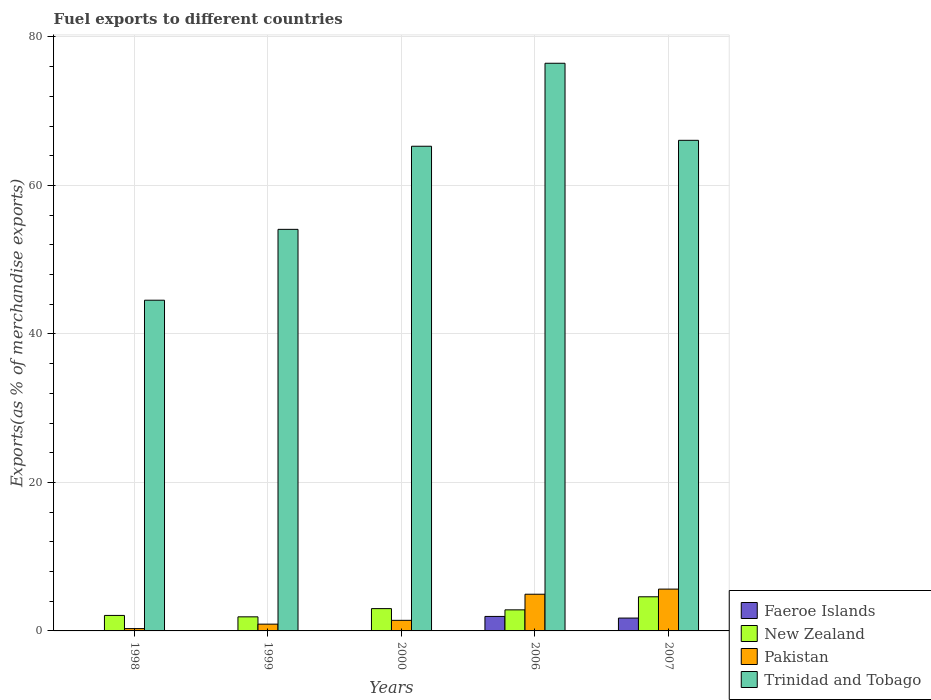How many different coloured bars are there?
Offer a terse response. 4. Are the number of bars per tick equal to the number of legend labels?
Your answer should be very brief. Yes. Are the number of bars on each tick of the X-axis equal?
Your answer should be very brief. Yes. How many bars are there on the 4th tick from the left?
Your answer should be compact. 4. How many bars are there on the 5th tick from the right?
Make the answer very short. 4. What is the label of the 1st group of bars from the left?
Make the answer very short. 1998. What is the percentage of exports to different countries in Trinidad and Tobago in 2007?
Your answer should be very brief. 66.08. Across all years, what is the maximum percentage of exports to different countries in Pakistan?
Give a very brief answer. 5.63. Across all years, what is the minimum percentage of exports to different countries in Faeroe Islands?
Provide a short and direct response. 5.55871303274651e-5. In which year was the percentage of exports to different countries in New Zealand maximum?
Offer a terse response. 2007. In which year was the percentage of exports to different countries in Pakistan minimum?
Give a very brief answer. 1998. What is the total percentage of exports to different countries in Pakistan in the graph?
Give a very brief answer. 13.23. What is the difference between the percentage of exports to different countries in Pakistan in 1998 and that in 2007?
Your answer should be very brief. -5.32. What is the difference between the percentage of exports to different countries in Trinidad and Tobago in 2000 and the percentage of exports to different countries in Pakistan in 1999?
Provide a short and direct response. 64.37. What is the average percentage of exports to different countries in Trinidad and Tobago per year?
Your response must be concise. 61.29. In the year 2007, what is the difference between the percentage of exports to different countries in Pakistan and percentage of exports to different countries in New Zealand?
Your answer should be very brief. 1.04. In how many years, is the percentage of exports to different countries in New Zealand greater than 4 %?
Your answer should be very brief. 1. What is the ratio of the percentage of exports to different countries in New Zealand in 1998 to that in 2000?
Offer a terse response. 0.69. Is the percentage of exports to different countries in New Zealand in 1998 less than that in 2006?
Your answer should be very brief. Yes. What is the difference between the highest and the second highest percentage of exports to different countries in Pakistan?
Your answer should be compact. 0.69. What is the difference between the highest and the lowest percentage of exports to different countries in Faeroe Islands?
Offer a very short reply. 1.95. In how many years, is the percentage of exports to different countries in New Zealand greater than the average percentage of exports to different countries in New Zealand taken over all years?
Offer a terse response. 2. What does the 1st bar from the left in 2006 represents?
Your answer should be compact. Faeroe Islands. Is it the case that in every year, the sum of the percentage of exports to different countries in Trinidad and Tobago and percentage of exports to different countries in New Zealand is greater than the percentage of exports to different countries in Faeroe Islands?
Offer a terse response. Yes. How many bars are there?
Ensure brevity in your answer.  20. Are all the bars in the graph horizontal?
Offer a terse response. No. What is the difference between two consecutive major ticks on the Y-axis?
Provide a short and direct response. 20. Are the values on the major ticks of Y-axis written in scientific E-notation?
Your answer should be compact. No. Does the graph contain any zero values?
Provide a succinct answer. No. Does the graph contain grids?
Ensure brevity in your answer.  Yes. How are the legend labels stacked?
Give a very brief answer. Vertical. What is the title of the graph?
Provide a short and direct response. Fuel exports to different countries. Does "Middle income" appear as one of the legend labels in the graph?
Your response must be concise. No. What is the label or title of the X-axis?
Make the answer very short. Years. What is the label or title of the Y-axis?
Provide a short and direct response. Exports(as % of merchandise exports). What is the Exports(as % of merchandise exports) in Faeroe Islands in 1998?
Your response must be concise. 0. What is the Exports(as % of merchandise exports) of New Zealand in 1998?
Make the answer very short. 2.09. What is the Exports(as % of merchandise exports) in Pakistan in 1998?
Ensure brevity in your answer.  0.31. What is the Exports(as % of merchandise exports) in Trinidad and Tobago in 1998?
Offer a very short reply. 44.54. What is the Exports(as % of merchandise exports) in Faeroe Islands in 1999?
Give a very brief answer. 0. What is the Exports(as % of merchandise exports) of New Zealand in 1999?
Your answer should be very brief. 1.9. What is the Exports(as % of merchandise exports) in Pakistan in 1999?
Your response must be concise. 0.91. What is the Exports(as % of merchandise exports) of Trinidad and Tobago in 1999?
Your response must be concise. 54.08. What is the Exports(as % of merchandise exports) in Faeroe Islands in 2000?
Give a very brief answer. 5.55871303274651e-5. What is the Exports(as % of merchandise exports) in New Zealand in 2000?
Your answer should be compact. 3. What is the Exports(as % of merchandise exports) in Pakistan in 2000?
Keep it short and to the point. 1.43. What is the Exports(as % of merchandise exports) of Trinidad and Tobago in 2000?
Give a very brief answer. 65.28. What is the Exports(as % of merchandise exports) of Faeroe Islands in 2006?
Offer a very short reply. 1.95. What is the Exports(as % of merchandise exports) in New Zealand in 2006?
Your answer should be very brief. 2.84. What is the Exports(as % of merchandise exports) in Pakistan in 2006?
Make the answer very short. 4.94. What is the Exports(as % of merchandise exports) of Trinidad and Tobago in 2006?
Ensure brevity in your answer.  76.46. What is the Exports(as % of merchandise exports) of Faeroe Islands in 2007?
Make the answer very short. 1.73. What is the Exports(as % of merchandise exports) in New Zealand in 2007?
Keep it short and to the point. 4.6. What is the Exports(as % of merchandise exports) of Pakistan in 2007?
Your response must be concise. 5.63. What is the Exports(as % of merchandise exports) in Trinidad and Tobago in 2007?
Keep it short and to the point. 66.08. Across all years, what is the maximum Exports(as % of merchandise exports) of Faeroe Islands?
Your answer should be very brief. 1.95. Across all years, what is the maximum Exports(as % of merchandise exports) of New Zealand?
Keep it short and to the point. 4.6. Across all years, what is the maximum Exports(as % of merchandise exports) of Pakistan?
Offer a very short reply. 5.63. Across all years, what is the maximum Exports(as % of merchandise exports) in Trinidad and Tobago?
Your answer should be compact. 76.46. Across all years, what is the minimum Exports(as % of merchandise exports) in Faeroe Islands?
Ensure brevity in your answer.  5.55871303274651e-5. Across all years, what is the minimum Exports(as % of merchandise exports) in New Zealand?
Your answer should be very brief. 1.9. Across all years, what is the minimum Exports(as % of merchandise exports) of Pakistan?
Make the answer very short. 0.31. Across all years, what is the minimum Exports(as % of merchandise exports) of Trinidad and Tobago?
Give a very brief answer. 44.54. What is the total Exports(as % of merchandise exports) in Faeroe Islands in the graph?
Your answer should be very brief. 3.68. What is the total Exports(as % of merchandise exports) in New Zealand in the graph?
Ensure brevity in your answer.  14.42. What is the total Exports(as % of merchandise exports) of Pakistan in the graph?
Provide a succinct answer. 13.23. What is the total Exports(as % of merchandise exports) in Trinidad and Tobago in the graph?
Your answer should be compact. 306.44. What is the difference between the Exports(as % of merchandise exports) in Faeroe Islands in 1998 and that in 1999?
Your response must be concise. -0. What is the difference between the Exports(as % of merchandise exports) of New Zealand in 1998 and that in 1999?
Your answer should be compact. 0.19. What is the difference between the Exports(as % of merchandise exports) of Pakistan in 1998 and that in 1999?
Provide a succinct answer. -0.6. What is the difference between the Exports(as % of merchandise exports) of Trinidad and Tobago in 1998 and that in 1999?
Offer a very short reply. -9.54. What is the difference between the Exports(as % of merchandise exports) of Faeroe Islands in 1998 and that in 2000?
Your answer should be very brief. 0. What is the difference between the Exports(as % of merchandise exports) in New Zealand in 1998 and that in 2000?
Provide a short and direct response. -0.92. What is the difference between the Exports(as % of merchandise exports) of Pakistan in 1998 and that in 2000?
Provide a succinct answer. -1.11. What is the difference between the Exports(as % of merchandise exports) of Trinidad and Tobago in 1998 and that in 2000?
Provide a short and direct response. -20.74. What is the difference between the Exports(as % of merchandise exports) of Faeroe Islands in 1998 and that in 2006?
Make the answer very short. -1.95. What is the difference between the Exports(as % of merchandise exports) in New Zealand in 1998 and that in 2006?
Offer a terse response. -0.75. What is the difference between the Exports(as % of merchandise exports) in Pakistan in 1998 and that in 2006?
Ensure brevity in your answer.  -4.63. What is the difference between the Exports(as % of merchandise exports) of Trinidad and Tobago in 1998 and that in 2006?
Ensure brevity in your answer.  -31.91. What is the difference between the Exports(as % of merchandise exports) of Faeroe Islands in 1998 and that in 2007?
Provide a succinct answer. -1.73. What is the difference between the Exports(as % of merchandise exports) of New Zealand in 1998 and that in 2007?
Your response must be concise. -2.51. What is the difference between the Exports(as % of merchandise exports) of Pakistan in 1998 and that in 2007?
Your answer should be compact. -5.32. What is the difference between the Exports(as % of merchandise exports) in Trinidad and Tobago in 1998 and that in 2007?
Your answer should be very brief. -21.53. What is the difference between the Exports(as % of merchandise exports) of Faeroe Islands in 1999 and that in 2000?
Your answer should be compact. 0. What is the difference between the Exports(as % of merchandise exports) of New Zealand in 1999 and that in 2000?
Your answer should be very brief. -1.11. What is the difference between the Exports(as % of merchandise exports) in Pakistan in 1999 and that in 2000?
Provide a succinct answer. -0.51. What is the difference between the Exports(as % of merchandise exports) of Trinidad and Tobago in 1999 and that in 2000?
Ensure brevity in your answer.  -11.19. What is the difference between the Exports(as % of merchandise exports) in Faeroe Islands in 1999 and that in 2006?
Make the answer very short. -1.95. What is the difference between the Exports(as % of merchandise exports) in New Zealand in 1999 and that in 2006?
Provide a short and direct response. -0.94. What is the difference between the Exports(as % of merchandise exports) in Pakistan in 1999 and that in 2006?
Provide a short and direct response. -4.03. What is the difference between the Exports(as % of merchandise exports) of Trinidad and Tobago in 1999 and that in 2006?
Keep it short and to the point. -22.37. What is the difference between the Exports(as % of merchandise exports) in Faeroe Islands in 1999 and that in 2007?
Keep it short and to the point. -1.73. What is the difference between the Exports(as % of merchandise exports) of New Zealand in 1999 and that in 2007?
Offer a very short reply. -2.7. What is the difference between the Exports(as % of merchandise exports) in Pakistan in 1999 and that in 2007?
Keep it short and to the point. -4.72. What is the difference between the Exports(as % of merchandise exports) of Trinidad and Tobago in 1999 and that in 2007?
Ensure brevity in your answer.  -11.99. What is the difference between the Exports(as % of merchandise exports) of Faeroe Islands in 2000 and that in 2006?
Offer a very short reply. -1.95. What is the difference between the Exports(as % of merchandise exports) in New Zealand in 2000 and that in 2006?
Ensure brevity in your answer.  0.17. What is the difference between the Exports(as % of merchandise exports) in Pakistan in 2000 and that in 2006?
Provide a short and direct response. -3.51. What is the difference between the Exports(as % of merchandise exports) in Trinidad and Tobago in 2000 and that in 2006?
Make the answer very short. -11.18. What is the difference between the Exports(as % of merchandise exports) in Faeroe Islands in 2000 and that in 2007?
Your answer should be very brief. -1.73. What is the difference between the Exports(as % of merchandise exports) of New Zealand in 2000 and that in 2007?
Your response must be concise. -1.59. What is the difference between the Exports(as % of merchandise exports) of Pakistan in 2000 and that in 2007?
Your answer should be compact. -4.21. What is the difference between the Exports(as % of merchandise exports) in Trinidad and Tobago in 2000 and that in 2007?
Provide a short and direct response. -0.8. What is the difference between the Exports(as % of merchandise exports) of Faeroe Islands in 2006 and that in 2007?
Your answer should be very brief. 0.22. What is the difference between the Exports(as % of merchandise exports) of New Zealand in 2006 and that in 2007?
Give a very brief answer. -1.76. What is the difference between the Exports(as % of merchandise exports) in Pakistan in 2006 and that in 2007?
Keep it short and to the point. -0.69. What is the difference between the Exports(as % of merchandise exports) in Trinidad and Tobago in 2006 and that in 2007?
Provide a short and direct response. 10.38. What is the difference between the Exports(as % of merchandise exports) of Faeroe Islands in 1998 and the Exports(as % of merchandise exports) of New Zealand in 1999?
Keep it short and to the point. -1.9. What is the difference between the Exports(as % of merchandise exports) of Faeroe Islands in 1998 and the Exports(as % of merchandise exports) of Pakistan in 1999?
Give a very brief answer. -0.91. What is the difference between the Exports(as % of merchandise exports) in Faeroe Islands in 1998 and the Exports(as % of merchandise exports) in Trinidad and Tobago in 1999?
Provide a succinct answer. -54.08. What is the difference between the Exports(as % of merchandise exports) in New Zealand in 1998 and the Exports(as % of merchandise exports) in Pakistan in 1999?
Ensure brevity in your answer.  1.17. What is the difference between the Exports(as % of merchandise exports) in New Zealand in 1998 and the Exports(as % of merchandise exports) in Trinidad and Tobago in 1999?
Your answer should be very brief. -52. What is the difference between the Exports(as % of merchandise exports) in Pakistan in 1998 and the Exports(as % of merchandise exports) in Trinidad and Tobago in 1999?
Offer a very short reply. -53.77. What is the difference between the Exports(as % of merchandise exports) in Faeroe Islands in 1998 and the Exports(as % of merchandise exports) in New Zealand in 2000?
Your answer should be very brief. -3. What is the difference between the Exports(as % of merchandise exports) in Faeroe Islands in 1998 and the Exports(as % of merchandise exports) in Pakistan in 2000?
Your answer should be very brief. -1.43. What is the difference between the Exports(as % of merchandise exports) of Faeroe Islands in 1998 and the Exports(as % of merchandise exports) of Trinidad and Tobago in 2000?
Give a very brief answer. -65.28. What is the difference between the Exports(as % of merchandise exports) in New Zealand in 1998 and the Exports(as % of merchandise exports) in Pakistan in 2000?
Keep it short and to the point. 0.66. What is the difference between the Exports(as % of merchandise exports) in New Zealand in 1998 and the Exports(as % of merchandise exports) in Trinidad and Tobago in 2000?
Offer a terse response. -63.19. What is the difference between the Exports(as % of merchandise exports) in Pakistan in 1998 and the Exports(as % of merchandise exports) in Trinidad and Tobago in 2000?
Keep it short and to the point. -64.97. What is the difference between the Exports(as % of merchandise exports) of Faeroe Islands in 1998 and the Exports(as % of merchandise exports) of New Zealand in 2006?
Offer a terse response. -2.84. What is the difference between the Exports(as % of merchandise exports) in Faeroe Islands in 1998 and the Exports(as % of merchandise exports) in Pakistan in 2006?
Your answer should be very brief. -4.94. What is the difference between the Exports(as % of merchandise exports) in Faeroe Islands in 1998 and the Exports(as % of merchandise exports) in Trinidad and Tobago in 2006?
Keep it short and to the point. -76.46. What is the difference between the Exports(as % of merchandise exports) of New Zealand in 1998 and the Exports(as % of merchandise exports) of Pakistan in 2006?
Offer a very short reply. -2.85. What is the difference between the Exports(as % of merchandise exports) of New Zealand in 1998 and the Exports(as % of merchandise exports) of Trinidad and Tobago in 2006?
Ensure brevity in your answer.  -74.37. What is the difference between the Exports(as % of merchandise exports) of Pakistan in 1998 and the Exports(as % of merchandise exports) of Trinidad and Tobago in 2006?
Your answer should be very brief. -76.14. What is the difference between the Exports(as % of merchandise exports) in Faeroe Islands in 1998 and the Exports(as % of merchandise exports) in New Zealand in 2007?
Give a very brief answer. -4.6. What is the difference between the Exports(as % of merchandise exports) of Faeroe Islands in 1998 and the Exports(as % of merchandise exports) of Pakistan in 2007?
Make the answer very short. -5.63. What is the difference between the Exports(as % of merchandise exports) in Faeroe Islands in 1998 and the Exports(as % of merchandise exports) in Trinidad and Tobago in 2007?
Keep it short and to the point. -66.08. What is the difference between the Exports(as % of merchandise exports) of New Zealand in 1998 and the Exports(as % of merchandise exports) of Pakistan in 2007?
Keep it short and to the point. -3.55. What is the difference between the Exports(as % of merchandise exports) in New Zealand in 1998 and the Exports(as % of merchandise exports) in Trinidad and Tobago in 2007?
Your response must be concise. -63.99. What is the difference between the Exports(as % of merchandise exports) of Pakistan in 1998 and the Exports(as % of merchandise exports) of Trinidad and Tobago in 2007?
Provide a succinct answer. -65.76. What is the difference between the Exports(as % of merchandise exports) in Faeroe Islands in 1999 and the Exports(as % of merchandise exports) in New Zealand in 2000?
Provide a short and direct response. -3. What is the difference between the Exports(as % of merchandise exports) in Faeroe Islands in 1999 and the Exports(as % of merchandise exports) in Pakistan in 2000?
Give a very brief answer. -1.43. What is the difference between the Exports(as % of merchandise exports) in Faeroe Islands in 1999 and the Exports(as % of merchandise exports) in Trinidad and Tobago in 2000?
Give a very brief answer. -65.28. What is the difference between the Exports(as % of merchandise exports) in New Zealand in 1999 and the Exports(as % of merchandise exports) in Pakistan in 2000?
Give a very brief answer. 0.47. What is the difference between the Exports(as % of merchandise exports) of New Zealand in 1999 and the Exports(as % of merchandise exports) of Trinidad and Tobago in 2000?
Offer a terse response. -63.38. What is the difference between the Exports(as % of merchandise exports) of Pakistan in 1999 and the Exports(as % of merchandise exports) of Trinidad and Tobago in 2000?
Provide a short and direct response. -64.37. What is the difference between the Exports(as % of merchandise exports) in Faeroe Islands in 1999 and the Exports(as % of merchandise exports) in New Zealand in 2006?
Provide a short and direct response. -2.84. What is the difference between the Exports(as % of merchandise exports) in Faeroe Islands in 1999 and the Exports(as % of merchandise exports) in Pakistan in 2006?
Ensure brevity in your answer.  -4.94. What is the difference between the Exports(as % of merchandise exports) of Faeroe Islands in 1999 and the Exports(as % of merchandise exports) of Trinidad and Tobago in 2006?
Your response must be concise. -76.45. What is the difference between the Exports(as % of merchandise exports) of New Zealand in 1999 and the Exports(as % of merchandise exports) of Pakistan in 2006?
Provide a short and direct response. -3.05. What is the difference between the Exports(as % of merchandise exports) of New Zealand in 1999 and the Exports(as % of merchandise exports) of Trinidad and Tobago in 2006?
Provide a short and direct response. -74.56. What is the difference between the Exports(as % of merchandise exports) in Pakistan in 1999 and the Exports(as % of merchandise exports) in Trinidad and Tobago in 2006?
Ensure brevity in your answer.  -75.54. What is the difference between the Exports(as % of merchandise exports) of Faeroe Islands in 1999 and the Exports(as % of merchandise exports) of New Zealand in 2007?
Provide a succinct answer. -4.6. What is the difference between the Exports(as % of merchandise exports) of Faeroe Islands in 1999 and the Exports(as % of merchandise exports) of Pakistan in 2007?
Give a very brief answer. -5.63. What is the difference between the Exports(as % of merchandise exports) of Faeroe Islands in 1999 and the Exports(as % of merchandise exports) of Trinidad and Tobago in 2007?
Provide a succinct answer. -66.08. What is the difference between the Exports(as % of merchandise exports) in New Zealand in 1999 and the Exports(as % of merchandise exports) in Pakistan in 2007?
Offer a very short reply. -3.74. What is the difference between the Exports(as % of merchandise exports) of New Zealand in 1999 and the Exports(as % of merchandise exports) of Trinidad and Tobago in 2007?
Ensure brevity in your answer.  -64.18. What is the difference between the Exports(as % of merchandise exports) in Pakistan in 1999 and the Exports(as % of merchandise exports) in Trinidad and Tobago in 2007?
Offer a very short reply. -65.16. What is the difference between the Exports(as % of merchandise exports) of Faeroe Islands in 2000 and the Exports(as % of merchandise exports) of New Zealand in 2006?
Offer a terse response. -2.84. What is the difference between the Exports(as % of merchandise exports) in Faeroe Islands in 2000 and the Exports(as % of merchandise exports) in Pakistan in 2006?
Make the answer very short. -4.94. What is the difference between the Exports(as % of merchandise exports) of Faeroe Islands in 2000 and the Exports(as % of merchandise exports) of Trinidad and Tobago in 2006?
Your answer should be very brief. -76.46. What is the difference between the Exports(as % of merchandise exports) in New Zealand in 2000 and the Exports(as % of merchandise exports) in Pakistan in 2006?
Your answer should be compact. -1.94. What is the difference between the Exports(as % of merchandise exports) of New Zealand in 2000 and the Exports(as % of merchandise exports) of Trinidad and Tobago in 2006?
Your answer should be compact. -73.45. What is the difference between the Exports(as % of merchandise exports) of Pakistan in 2000 and the Exports(as % of merchandise exports) of Trinidad and Tobago in 2006?
Keep it short and to the point. -75.03. What is the difference between the Exports(as % of merchandise exports) in Faeroe Islands in 2000 and the Exports(as % of merchandise exports) in New Zealand in 2007?
Make the answer very short. -4.6. What is the difference between the Exports(as % of merchandise exports) of Faeroe Islands in 2000 and the Exports(as % of merchandise exports) of Pakistan in 2007?
Offer a terse response. -5.63. What is the difference between the Exports(as % of merchandise exports) in Faeroe Islands in 2000 and the Exports(as % of merchandise exports) in Trinidad and Tobago in 2007?
Keep it short and to the point. -66.08. What is the difference between the Exports(as % of merchandise exports) in New Zealand in 2000 and the Exports(as % of merchandise exports) in Pakistan in 2007?
Offer a very short reply. -2.63. What is the difference between the Exports(as % of merchandise exports) of New Zealand in 2000 and the Exports(as % of merchandise exports) of Trinidad and Tobago in 2007?
Your answer should be very brief. -63.07. What is the difference between the Exports(as % of merchandise exports) of Pakistan in 2000 and the Exports(as % of merchandise exports) of Trinidad and Tobago in 2007?
Offer a very short reply. -64.65. What is the difference between the Exports(as % of merchandise exports) of Faeroe Islands in 2006 and the Exports(as % of merchandise exports) of New Zealand in 2007?
Provide a short and direct response. -2.65. What is the difference between the Exports(as % of merchandise exports) of Faeroe Islands in 2006 and the Exports(as % of merchandise exports) of Pakistan in 2007?
Offer a terse response. -3.68. What is the difference between the Exports(as % of merchandise exports) in Faeroe Islands in 2006 and the Exports(as % of merchandise exports) in Trinidad and Tobago in 2007?
Your answer should be very brief. -64.12. What is the difference between the Exports(as % of merchandise exports) in New Zealand in 2006 and the Exports(as % of merchandise exports) in Pakistan in 2007?
Your response must be concise. -2.8. What is the difference between the Exports(as % of merchandise exports) in New Zealand in 2006 and the Exports(as % of merchandise exports) in Trinidad and Tobago in 2007?
Offer a very short reply. -63.24. What is the difference between the Exports(as % of merchandise exports) of Pakistan in 2006 and the Exports(as % of merchandise exports) of Trinidad and Tobago in 2007?
Make the answer very short. -61.13. What is the average Exports(as % of merchandise exports) in Faeroe Islands per year?
Provide a succinct answer. 0.74. What is the average Exports(as % of merchandise exports) in New Zealand per year?
Your response must be concise. 2.88. What is the average Exports(as % of merchandise exports) of Pakistan per year?
Keep it short and to the point. 2.65. What is the average Exports(as % of merchandise exports) in Trinidad and Tobago per year?
Give a very brief answer. 61.29. In the year 1998, what is the difference between the Exports(as % of merchandise exports) of Faeroe Islands and Exports(as % of merchandise exports) of New Zealand?
Give a very brief answer. -2.09. In the year 1998, what is the difference between the Exports(as % of merchandise exports) of Faeroe Islands and Exports(as % of merchandise exports) of Pakistan?
Give a very brief answer. -0.31. In the year 1998, what is the difference between the Exports(as % of merchandise exports) of Faeroe Islands and Exports(as % of merchandise exports) of Trinidad and Tobago?
Make the answer very short. -44.54. In the year 1998, what is the difference between the Exports(as % of merchandise exports) of New Zealand and Exports(as % of merchandise exports) of Pakistan?
Your answer should be very brief. 1.77. In the year 1998, what is the difference between the Exports(as % of merchandise exports) of New Zealand and Exports(as % of merchandise exports) of Trinidad and Tobago?
Your answer should be very brief. -42.45. In the year 1998, what is the difference between the Exports(as % of merchandise exports) in Pakistan and Exports(as % of merchandise exports) in Trinidad and Tobago?
Provide a succinct answer. -44.23. In the year 1999, what is the difference between the Exports(as % of merchandise exports) in Faeroe Islands and Exports(as % of merchandise exports) in New Zealand?
Make the answer very short. -1.9. In the year 1999, what is the difference between the Exports(as % of merchandise exports) of Faeroe Islands and Exports(as % of merchandise exports) of Pakistan?
Make the answer very short. -0.91. In the year 1999, what is the difference between the Exports(as % of merchandise exports) in Faeroe Islands and Exports(as % of merchandise exports) in Trinidad and Tobago?
Your answer should be very brief. -54.08. In the year 1999, what is the difference between the Exports(as % of merchandise exports) in New Zealand and Exports(as % of merchandise exports) in Pakistan?
Your answer should be very brief. 0.98. In the year 1999, what is the difference between the Exports(as % of merchandise exports) of New Zealand and Exports(as % of merchandise exports) of Trinidad and Tobago?
Your answer should be very brief. -52.19. In the year 1999, what is the difference between the Exports(as % of merchandise exports) of Pakistan and Exports(as % of merchandise exports) of Trinidad and Tobago?
Make the answer very short. -53.17. In the year 2000, what is the difference between the Exports(as % of merchandise exports) in Faeroe Islands and Exports(as % of merchandise exports) in New Zealand?
Your answer should be very brief. -3. In the year 2000, what is the difference between the Exports(as % of merchandise exports) of Faeroe Islands and Exports(as % of merchandise exports) of Pakistan?
Keep it short and to the point. -1.43. In the year 2000, what is the difference between the Exports(as % of merchandise exports) of Faeroe Islands and Exports(as % of merchandise exports) of Trinidad and Tobago?
Make the answer very short. -65.28. In the year 2000, what is the difference between the Exports(as % of merchandise exports) of New Zealand and Exports(as % of merchandise exports) of Pakistan?
Your response must be concise. 1.58. In the year 2000, what is the difference between the Exports(as % of merchandise exports) in New Zealand and Exports(as % of merchandise exports) in Trinidad and Tobago?
Your response must be concise. -62.27. In the year 2000, what is the difference between the Exports(as % of merchandise exports) of Pakistan and Exports(as % of merchandise exports) of Trinidad and Tobago?
Give a very brief answer. -63.85. In the year 2006, what is the difference between the Exports(as % of merchandise exports) of Faeroe Islands and Exports(as % of merchandise exports) of New Zealand?
Provide a short and direct response. -0.89. In the year 2006, what is the difference between the Exports(as % of merchandise exports) of Faeroe Islands and Exports(as % of merchandise exports) of Pakistan?
Keep it short and to the point. -2.99. In the year 2006, what is the difference between the Exports(as % of merchandise exports) of Faeroe Islands and Exports(as % of merchandise exports) of Trinidad and Tobago?
Provide a short and direct response. -74.5. In the year 2006, what is the difference between the Exports(as % of merchandise exports) in New Zealand and Exports(as % of merchandise exports) in Pakistan?
Keep it short and to the point. -2.1. In the year 2006, what is the difference between the Exports(as % of merchandise exports) in New Zealand and Exports(as % of merchandise exports) in Trinidad and Tobago?
Ensure brevity in your answer.  -73.62. In the year 2006, what is the difference between the Exports(as % of merchandise exports) of Pakistan and Exports(as % of merchandise exports) of Trinidad and Tobago?
Provide a succinct answer. -71.51. In the year 2007, what is the difference between the Exports(as % of merchandise exports) of Faeroe Islands and Exports(as % of merchandise exports) of New Zealand?
Offer a very short reply. -2.87. In the year 2007, what is the difference between the Exports(as % of merchandise exports) of Faeroe Islands and Exports(as % of merchandise exports) of Pakistan?
Your response must be concise. -3.9. In the year 2007, what is the difference between the Exports(as % of merchandise exports) in Faeroe Islands and Exports(as % of merchandise exports) in Trinidad and Tobago?
Keep it short and to the point. -64.35. In the year 2007, what is the difference between the Exports(as % of merchandise exports) of New Zealand and Exports(as % of merchandise exports) of Pakistan?
Your response must be concise. -1.04. In the year 2007, what is the difference between the Exports(as % of merchandise exports) in New Zealand and Exports(as % of merchandise exports) in Trinidad and Tobago?
Your response must be concise. -61.48. In the year 2007, what is the difference between the Exports(as % of merchandise exports) of Pakistan and Exports(as % of merchandise exports) of Trinidad and Tobago?
Your answer should be very brief. -60.44. What is the ratio of the Exports(as % of merchandise exports) of Faeroe Islands in 1998 to that in 1999?
Ensure brevity in your answer.  0.28. What is the ratio of the Exports(as % of merchandise exports) in New Zealand in 1998 to that in 1999?
Give a very brief answer. 1.1. What is the ratio of the Exports(as % of merchandise exports) of Pakistan in 1998 to that in 1999?
Keep it short and to the point. 0.34. What is the ratio of the Exports(as % of merchandise exports) of Trinidad and Tobago in 1998 to that in 1999?
Provide a short and direct response. 0.82. What is the ratio of the Exports(as % of merchandise exports) in Faeroe Islands in 1998 to that in 2000?
Your answer should be very brief. 4.16. What is the ratio of the Exports(as % of merchandise exports) of New Zealand in 1998 to that in 2000?
Give a very brief answer. 0.69. What is the ratio of the Exports(as % of merchandise exports) in Pakistan in 1998 to that in 2000?
Your answer should be compact. 0.22. What is the ratio of the Exports(as % of merchandise exports) in Trinidad and Tobago in 1998 to that in 2000?
Offer a terse response. 0.68. What is the ratio of the Exports(as % of merchandise exports) in Faeroe Islands in 1998 to that in 2006?
Your response must be concise. 0. What is the ratio of the Exports(as % of merchandise exports) in New Zealand in 1998 to that in 2006?
Your answer should be compact. 0.74. What is the ratio of the Exports(as % of merchandise exports) in Pakistan in 1998 to that in 2006?
Provide a succinct answer. 0.06. What is the ratio of the Exports(as % of merchandise exports) in Trinidad and Tobago in 1998 to that in 2006?
Provide a short and direct response. 0.58. What is the ratio of the Exports(as % of merchandise exports) in Faeroe Islands in 1998 to that in 2007?
Provide a short and direct response. 0. What is the ratio of the Exports(as % of merchandise exports) in New Zealand in 1998 to that in 2007?
Ensure brevity in your answer.  0.45. What is the ratio of the Exports(as % of merchandise exports) of Pakistan in 1998 to that in 2007?
Your response must be concise. 0.06. What is the ratio of the Exports(as % of merchandise exports) in Trinidad and Tobago in 1998 to that in 2007?
Make the answer very short. 0.67. What is the ratio of the Exports(as % of merchandise exports) in Faeroe Islands in 1999 to that in 2000?
Give a very brief answer. 15.06. What is the ratio of the Exports(as % of merchandise exports) of New Zealand in 1999 to that in 2000?
Give a very brief answer. 0.63. What is the ratio of the Exports(as % of merchandise exports) in Pakistan in 1999 to that in 2000?
Your response must be concise. 0.64. What is the ratio of the Exports(as % of merchandise exports) of Trinidad and Tobago in 1999 to that in 2000?
Offer a terse response. 0.83. What is the ratio of the Exports(as % of merchandise exports) of Faeroe Islands in 1999 to that in 2006?
Keep it short and to the point. 0. What is the ratio of the Exports(as % of merchandise exports) of New Zealand in 1999 to that in 2006?
Keep it short and to the point. 0.67. What is the ratio of the Exports(as % of merchandise exports) of Pakistan in 1999 to that in 2006?
Ensure brevity in your answer.  0.18. What is the ratio of the Exports(as % of merchandise exports) in Trinidad and Tobago in 1999 to that in 2006?
Your answer should be very brief. 0.71. What is the ratio of the Exports(as % of merchandise exports) in New Zealand in 1999 to that in 2007?
Make the answer very short. 0.41. What is the ratio of the Exports(as % of merchandise exports) of Pakistan in 1999 to that in 2007?
Keep it short and to the point. 0.16. What is the ratio of the Exports(as % of merchandise exports) in Trinidad and Tobago in 1999 to that in 2007?
Make the answer very short. 0.82. What is the ratio of the Exports(as % of merchandise exports) of Faeroe Islands in 2000 to that in 2006?
Ensure brevity in your answer.  0. What is the ratio of the Exports(as % of merchandise exports) of New Zealand in 2000 to that in 2006?
Ensure brevity in your answer.  1.06. What is the ratio of the Exports(as % of merchandise exports) of Pakistan in 2000 to that in 2006?
Your answer should be compact. 0.29. What is the ratio of the Exports(as % of merchandise exports) in Trinidad and Tobago in 2000 to that in 2006?
Make the answer very short. 0.85. What is the ratio of the Exports(as % of merchandise exports) in New Zealand in 2000 to that in 2007?
Your answer should be compact. 0.65. What is the ratio of the Exports(as % of merchandise exports) in Pakistan in 2000 to that in 2007?
Provide a succinct answer. 0.25. What is the ratio of the Exports(as % of merchandise exports) of Trinidad and Tobago in 2000 to that in 2007?
Provide a short and direct response. 0.99. What is the ratio of the Exports(as % of merchandise exports) of Faeroe Islands in 2006 to that in 2007?
Your answer should be compact. 1.13. What is the ratio of the Exports(as % of merchandise exports) of New Zealand in 2006 to that in 2007?
Give a very brief answer. 0.62. What is the ratio of the Exports(as % of merchandise exports) of Pakistan in 2006 to that in 2007?
Your answer should be very brief. 0.88. What is the ratio of the Exports(as % of merchandise exports) in Trinidad and Tobago in 2006 to that in 2007?
Offer a terse response. 1.16. What is the difference between the highest and the second highest Exports(as % of merchandise exports) of Faeroe Islands?
Make the answer very short. 0.22. What is the difference between the highest and the second highest Exports(as % of merchandise exports) of New Zealand?
Your response must be concise. 1.59. What is the difference between the highest and the second highest Exports(as % of merchandise exports) of Pakistan?
Provide a short and direct response. 0.69. What is the difference between the highest and the second highest Exports(as % of merchandise exports) in Trinidad and Tobago?
Provide a short and direct response. 10.38. What is the difference between the highest and the lowest Exports(as % of merchandise exports) in Faeroe Islands?
Provide a short and direct response. 1.95. What is the difference between the highest and the lowest Exports(as % of merchandise exports) in New Zealand?
Provide a short and direct response. 2.7. What is the difference between the highest and the lowest Exports(as % of merchandise exports) in Pakistan?
Ensure brevity in your answer.  5.32. What is the difference between the highest and the lowest Exports(as % of merchandise exports) of Trinidad and Tobago?
Provide a succinct answer. 31.91. 